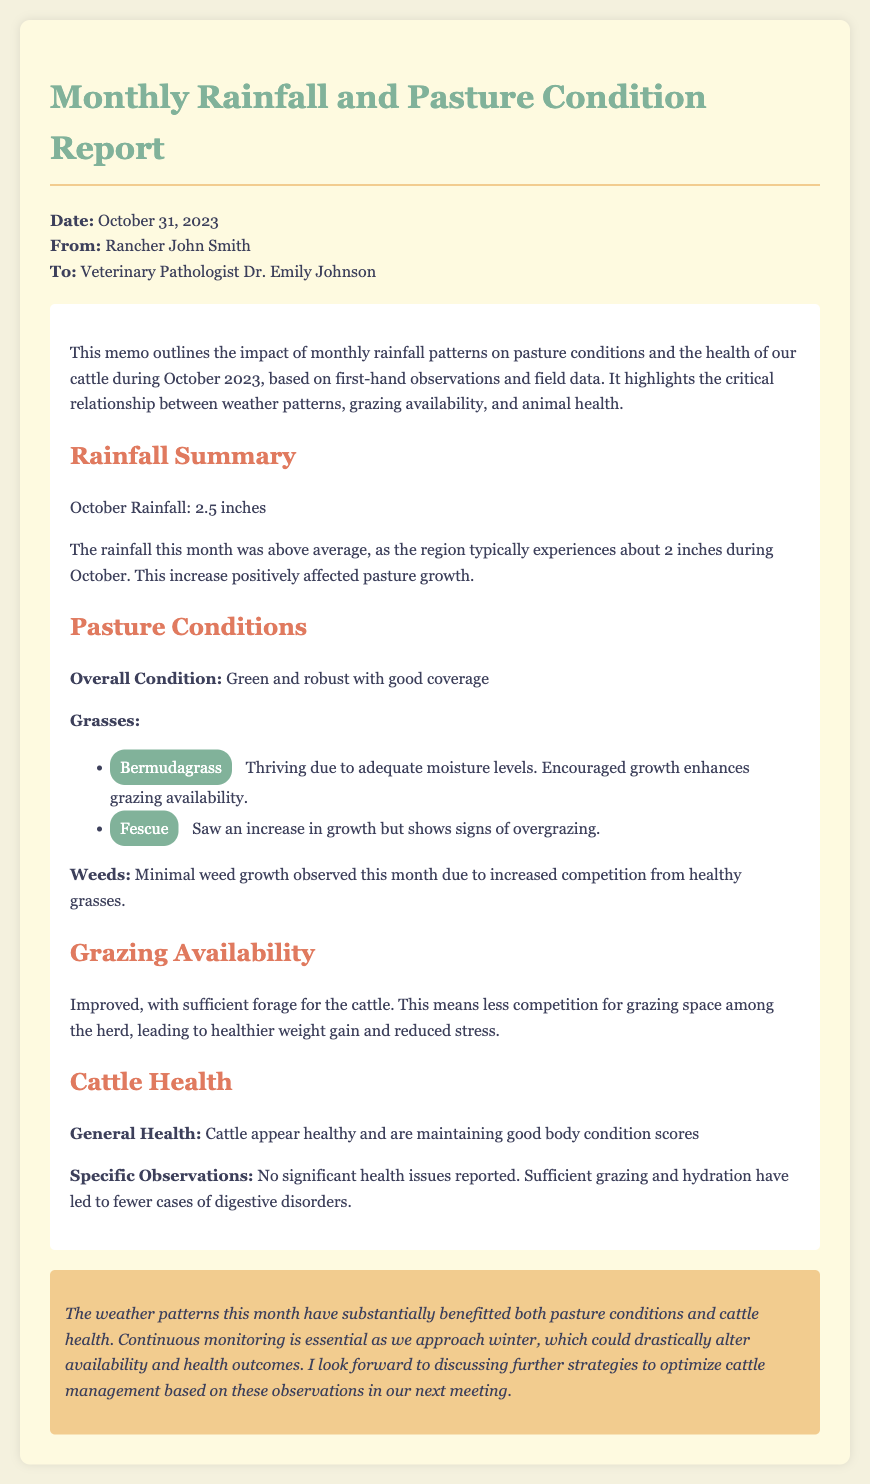What is the total rainfall in October 2023? The total rainfall for October 2023, as stated in the document, is 2.5 inches.
Answer: 2.5 inches What is the typical rainfall during October? The document mentions that the region typically experiences about 2 inches of rainfall during October.
Answer: 2 inches What type of grass showed signs of overgrazing? The memo mentions that Fescue shows signs of overgrazing.
Answer: Fescue What is the overall condition of the pasture? The document describes the overall condition of the pasture as green and robust with good coverage.
Answer: Green and robust with good coverage How many health issues were reported among the cattle? The memo states that no significant health issues were reported, indicating a positive health status.
Answer: No significant health issues Why is grazing availability described as improved? The document explains that improved grazing availability is due to sufficient forage for the cattle, leading to less competition for grazing space.
Answer: Sufficient forage What does the memo suggest for future cattle management? The conclusion indicates that continuous monitoring is essential and looks forward to discussing further strategies in the next meeting.
Answer: Continuous monitoring What is the main benefit of the weather patterns this month? The memo concludes that the weather patterns have substantially benefitted both pasture conditions and cattle health.
Answer: Benefitted pasture conditions and cattle health 